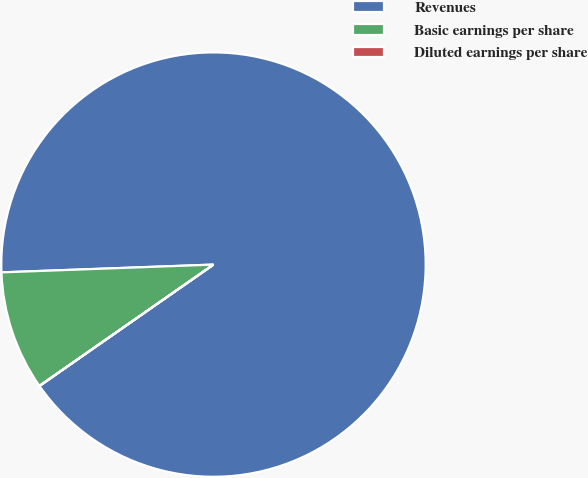<chart> <loc_0><loc_0><loc_500><loc_500><pie_chart><fcel>Revenues<fcel>Basic earnings per share<fcel>Diluted earnings per share<nl><fcel>90.89%<fcel>9.1%<fcel>0.01%<nl></chart> 